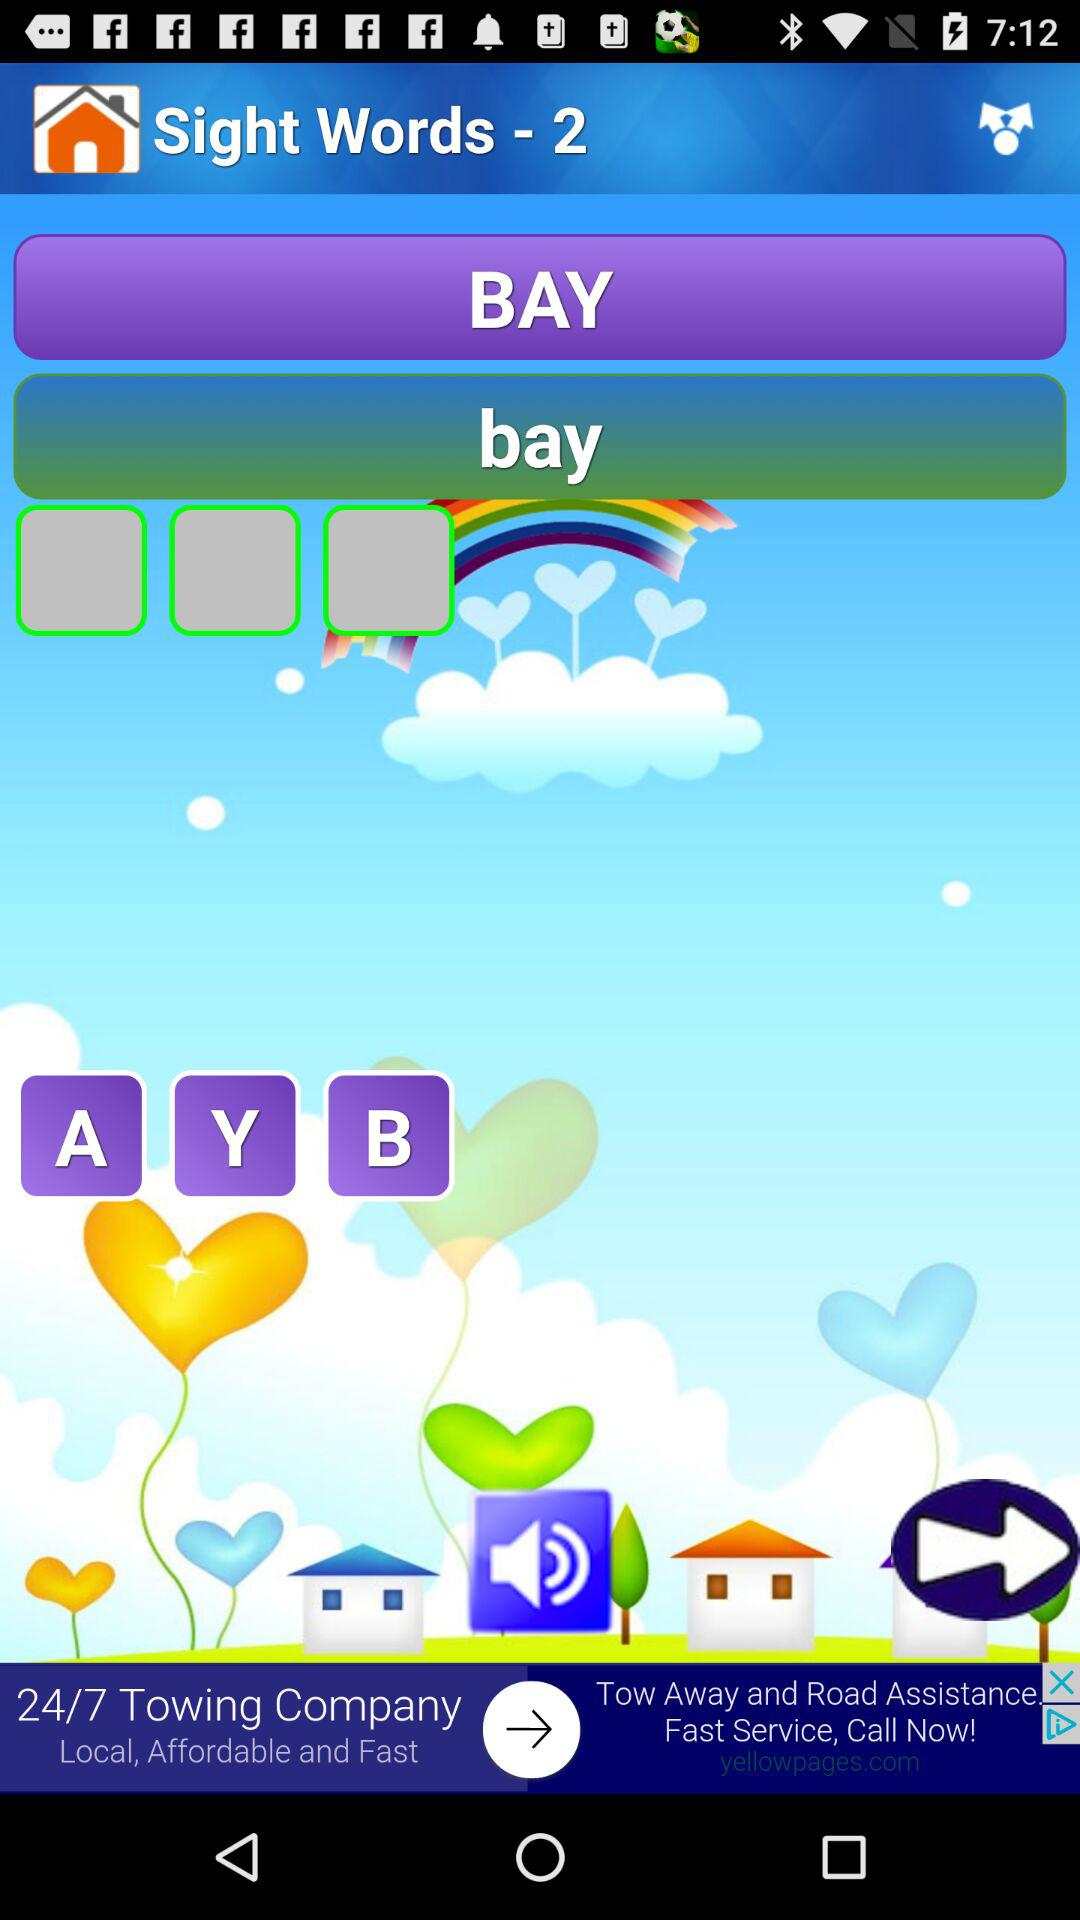What level is the volume?
When the provided information is insufficient, respond with <no answer>. <no answer> 